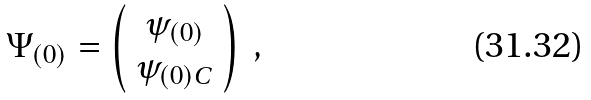Convert formula to latex. <formula><loc_0><loc_0><loc_500><loc_500>\Psi _ { ( 0 ) } = \left ( \begin{array} { c } \psi _ { ( 0 ) } \\ \psi _ { ( 0 ) C } \end{array} \right ) \ ,</formula> 